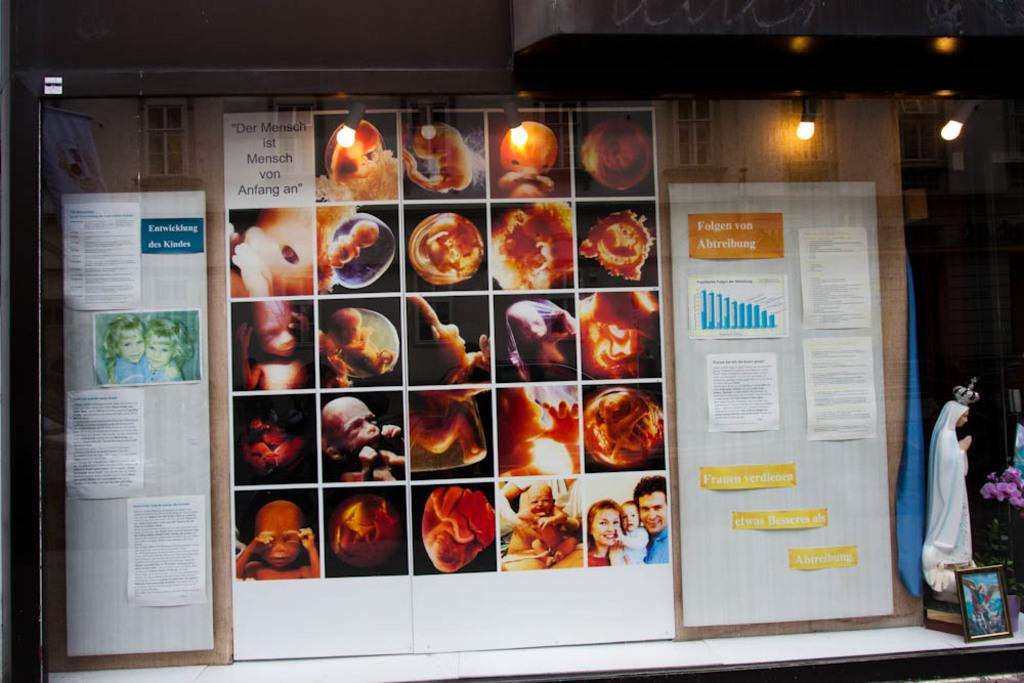What is attached to the board in the image? There are pamphlets attached to a board in the image. What can be seen at the top of the image? There are lights visible at the top of the image. What is the prominent sculpture in the image? There is a statue in the image. What is present on the table in the image? There are objects on a table in the image. How does the beggar interact with the statue in the image? There is no beggar present in the image, so no interaction with the statue can be observed. What color is the tongue of the statue in the image? There is no tongue visible on the statue in the image. 